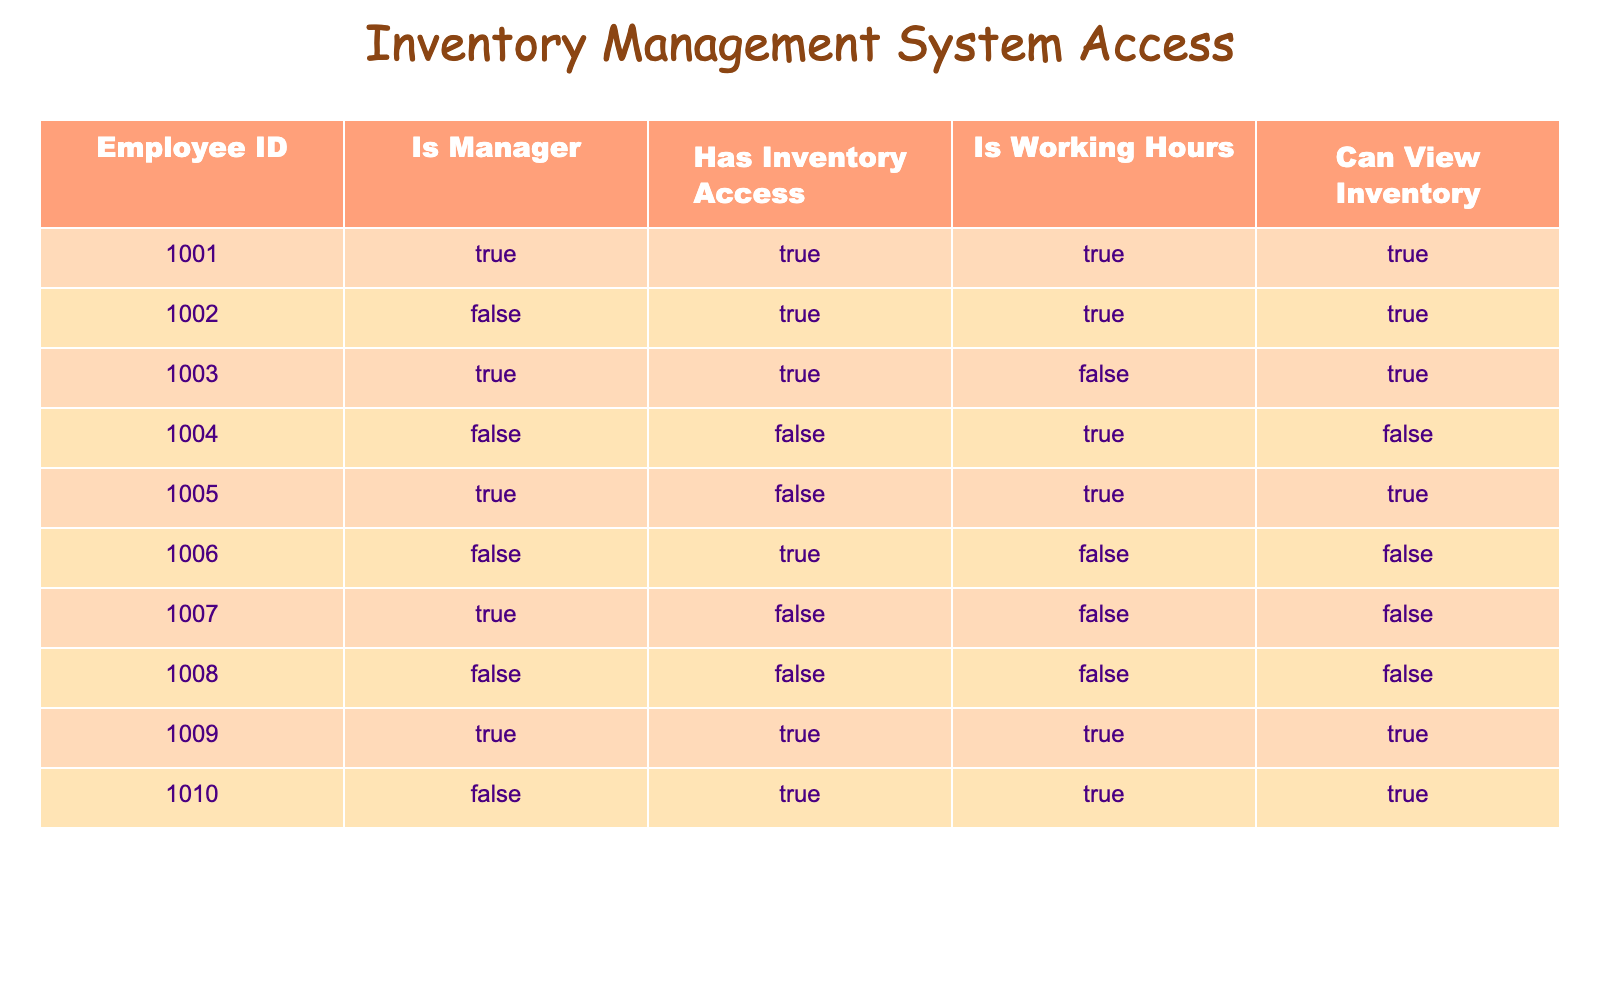What is the Employee ID of the manager who has inventory access and is working? In the table, we look for rows where "Is Manager" is TRUE, "Has Inventory Access" is TRUE, and "Is Working Hours" is TRUE. The only row fulfilling all three conditions is for Employee ID 1001.
Answer: 1001 How many employees have both inventory access and are working? To find this, we need to look at the "Has Inventory Access" and "Is Working Hours" columns. Counting the TRUE values in both columns, we see that there are 5 employees (1001, 1002, 1009, 1010, and 1006).
Answer: 5 Is there an employee who is not a manager yet has inventory access? We check the rows where "Is Manager" is FALSE and "Has Inventory Access" is TRUE. The employees with IDs 1002 and 1006 meet this criteria, so the answer is yes.
Answer: Yes What is the total number of employees who can view the inventory? "Can View Inventory" is TRUE for employees 1001, 1002, 1003, 1009, and 1010. Therefore, we have a total of 5 employees who can view the inventory.
Answer: 5 How many employees are both managers and cannot access the inventory? We filter by "Is Manager" being TRUE and "Has Inventory Access" being FALSE. Only Employee IDs 1005 and 1007 fit this criteria, resulting in 2 such employees.
Answer: 2 Are any employees working non-working hours but still have the ability to view the inventory? We check the "Is Working Hours" column for FALSE and "Can View Inventory" for TRUE. In this case, no employees meet these conditions.
Answer: No Which employee has the lowest Employee ID who has inventory access but is not a manager? We look at rows with "Is Manager" as FALSE and "Has Inventory Access" as TRUE. The employee with the lowest ID satisfying this condition is 1002.
Answer: 1002 How many managers can view the inventory? We check the "Is Manager" column for TRUE and "Can View Inventory" for TRUE. The matching Employee IDs are 1001, 1003, and 1009, so there are 3 managers who can view the inventory.
Answer: 3 Is there any employee who has inventory access but is not working? We look for "Has Inventory Access" being TRUE and "Is Working Hours" being FALSE. Employee 1006 resulted in NULL; therefore, the answer is yes, because the employees with IDs 1005 and 1007 meet the conditions.
Answer: Yes 